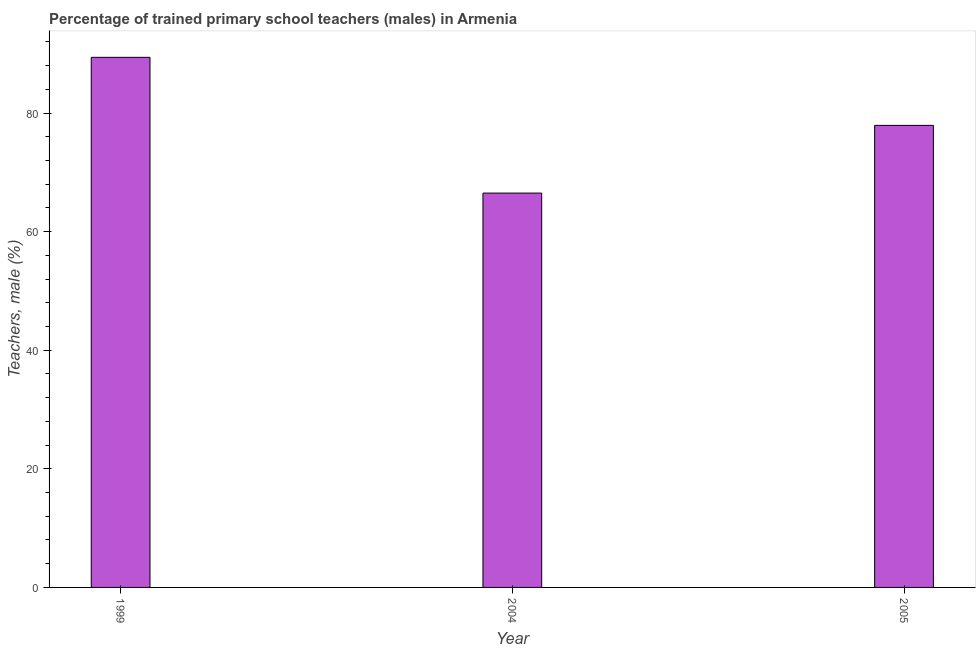Does the graph contain any zero values?
Offer a very short reply. No. Does the graph contain grids?
Ensure brevity in your answer.  No. What is the title of the graph?
Make the answer very short. Percentage of trained primary school teachers (males) in Armenia. What is the label or title of the Y-axis?
Provide a short and direct response. Teachers, male (%). What is the percentage of trained male teachers in 2004?
Provide a succinct answer. 66.5. Across all years, what is the maximum percentage of trained male teachers?
Offer a very short reply. 89.39. Across all years, what is the minimum percentage of trained male teachers?
Ensure brevity in your answer.  66.5. In which year was the percentage of trained male teachers minimum?
Your response must be concise. 2004. What is the sum of the percentage of trained male teachers?
Provide a succinct answer. 233.81. What is the difference between the percentage of trained male teachers in 1999 and 2004?
Your answer should be very brief. 22.89. What is the average percentage of trained male teachers per year?
Your answer should be very brief. 77.94. What is the median percentage of trained male teachers?
Offer a terse response. 77.92. Do a majority of the years between 1999 and 2005 (inclusive) have percentage of trained male teachers greater than 28 %?
Your response must be concise. Yes. What is the ratio of the percentage of trained male teachers in 2004 to that in 2005?
Your response must be concise. 0.85. Is the difference between the percentage of trained male teachers in 1999 and 2004 greater than the difference between any two years?
Offer a terse response. Yes. What is the difference between the highest and the second highest percentage of trained male teachers?
Provide a short and direct response. 11.48. Is the sum of the percentage of trained male teachers in 1999 and 2004 greater than the maximum percentage of trained male teachers across all years?
Make the answer very short. Yes. What is the difference between the highest and the lowest percentage of trained male teachers?
Your answer should be very brief. 22.89. How many bars are there?
Ensure brevity in your answer.  3. How many years are there in the graph?
Offer a very short reply. 3. What is the difference between two consecutive major ticks on the Y-axis?
Your response must be concise. 20. What is the Teachers, male (%) of 1999?
Make the answer very short. 89.39. What is the Teachers, male (%) in 2004?
Provide a succinct answer. 66.5. What is the Teachers, male (%) in 2005?
Your answer should be compact. 77.92. What is the difference between the Teachers, male (%) in 1999 and 2004?
Give a very brief answer. 22.89. What is the difference between the Teachers, male (%) in 1999 and 2005?
Offer a very short reply. 11.48. What is the difference between the Teachers, male (%) in 2004 and 2005?
Offer a terse response. -11.42. What is the ratio of the Teachers, male (%) in 1999 to that in 2004?
Provide a succinct answer. 1.34. What is the ratio of the Teachers, male (%) in 1999 to that in 2005?
Offer a terse response. 1.15. What is the ratio of the Teachers, male (%) in 2004 to that in 2005?
Offer a very short reply. 0.85. 